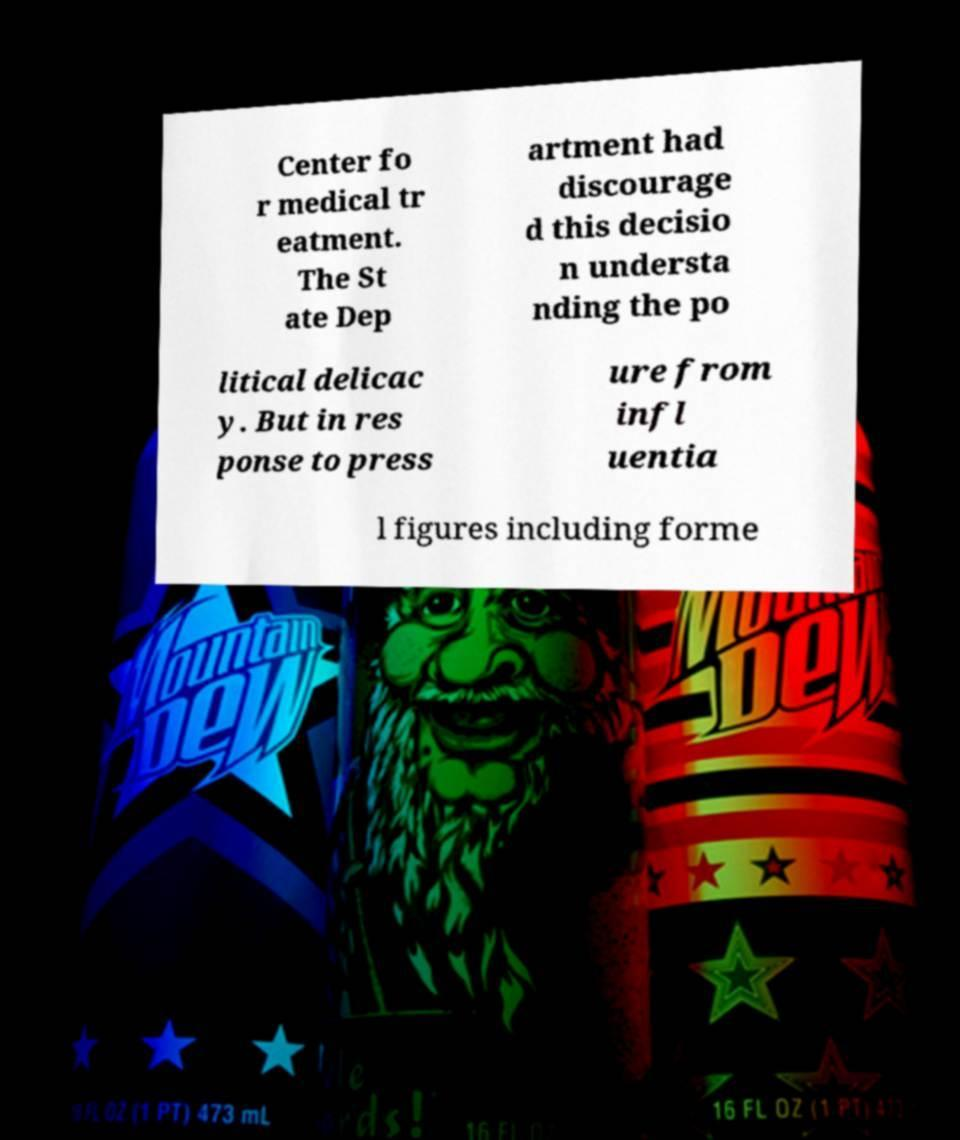There's text embedded in this image that I need extracted. Can you transcribe it verbatim? Center fo r medical tr eatment. The St ate Dep artment had discourage d this decisio n understa nding the po litical delicac y. But in res ponse to press ure from infl uentia l figures including forme 